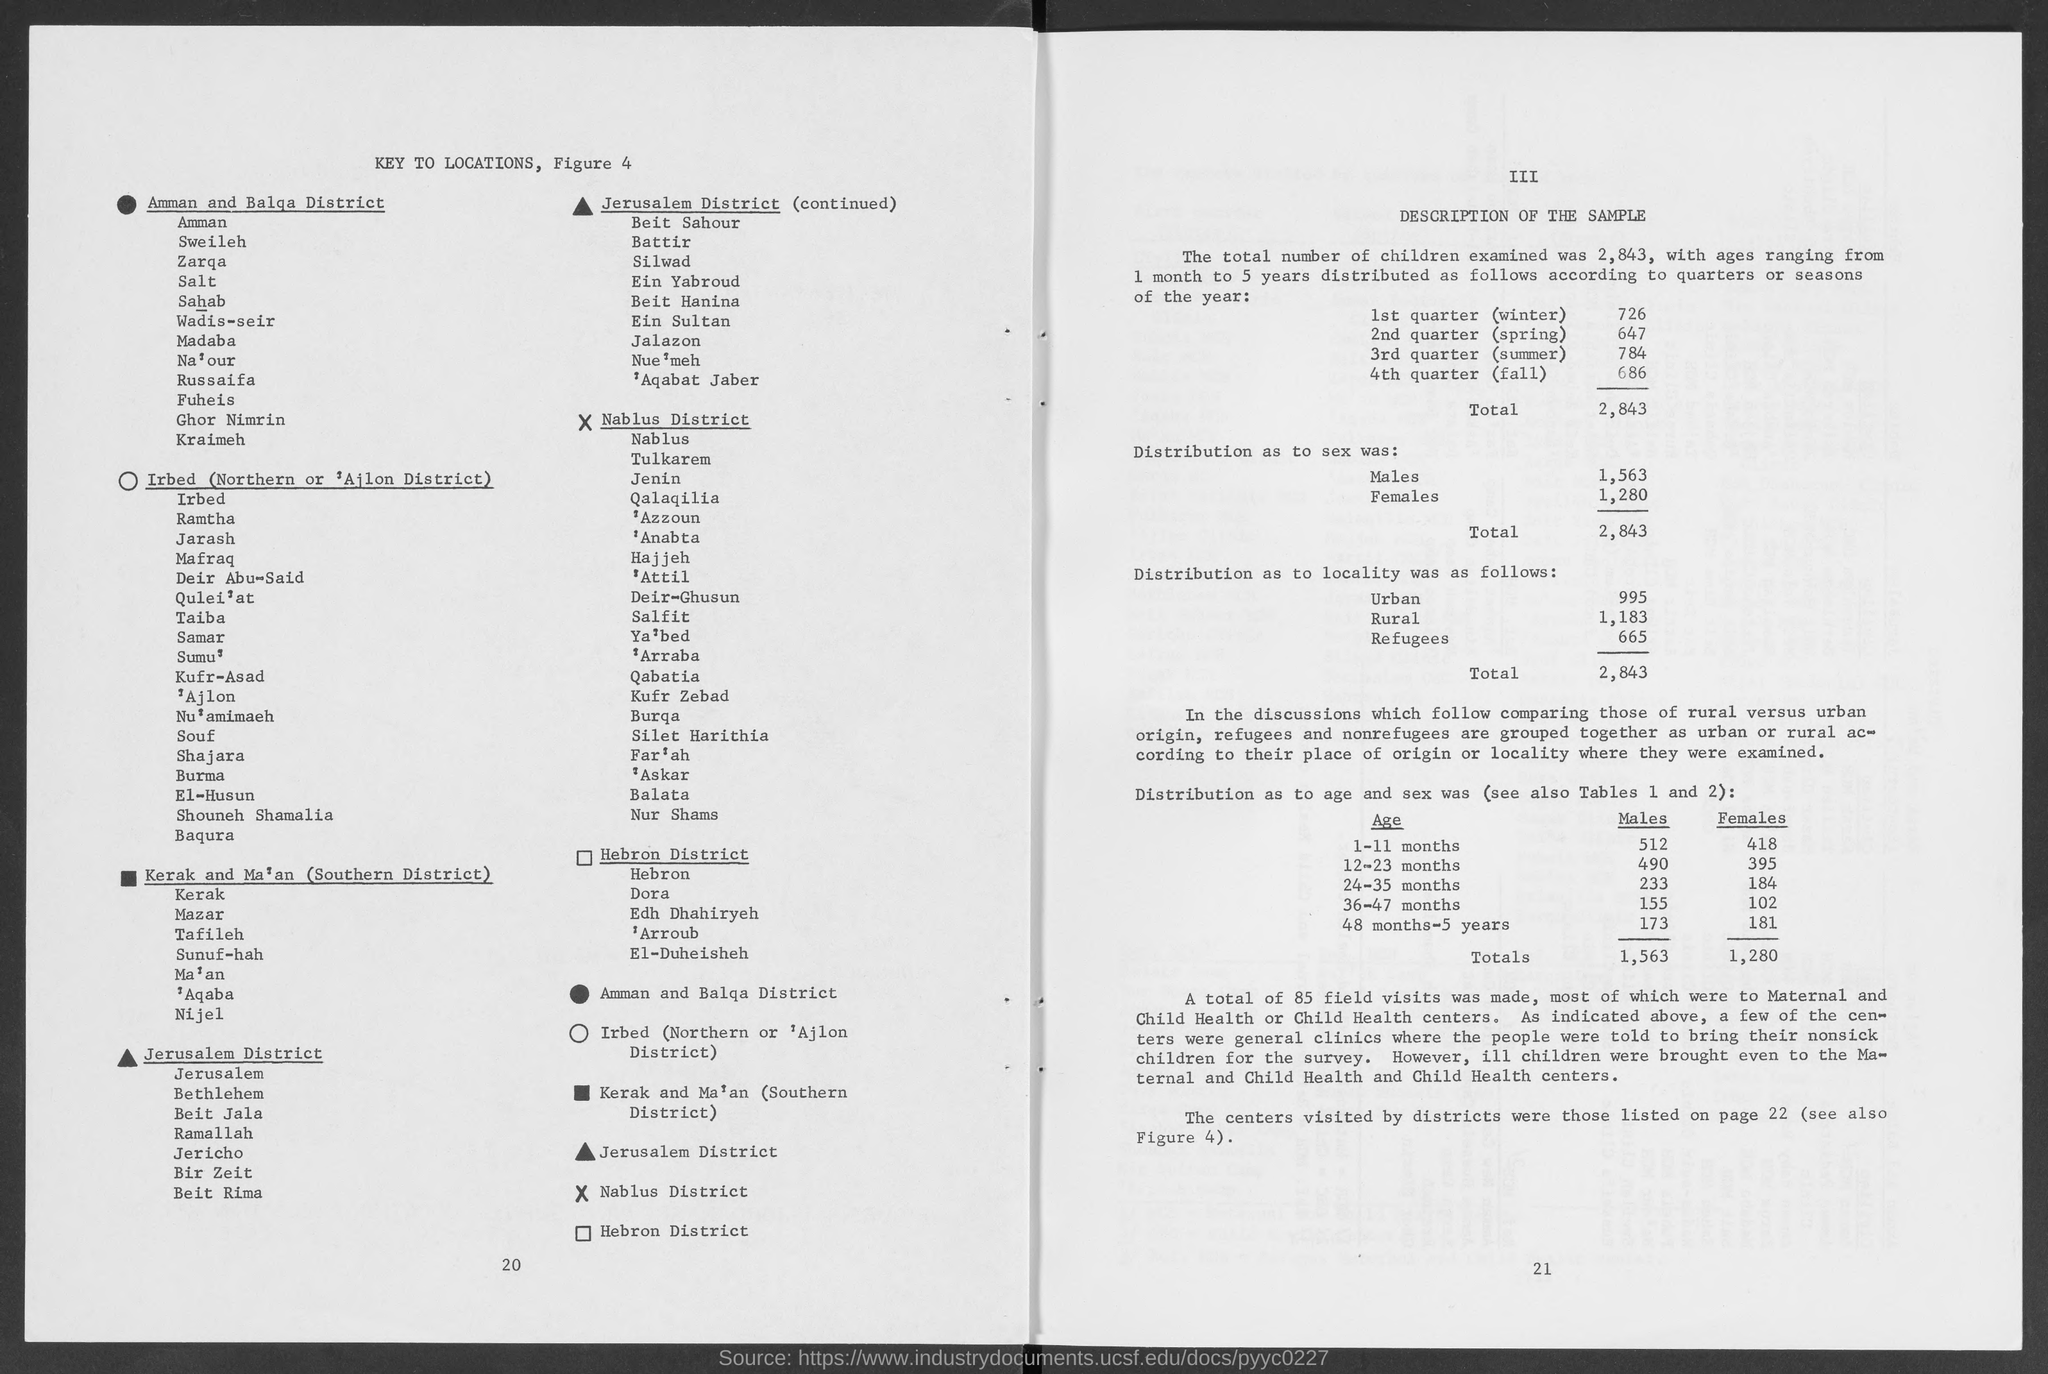Highlight a few significant elements in this photo. The number at the bottom right page is 21. The number at the bottom of the left page is 20. 